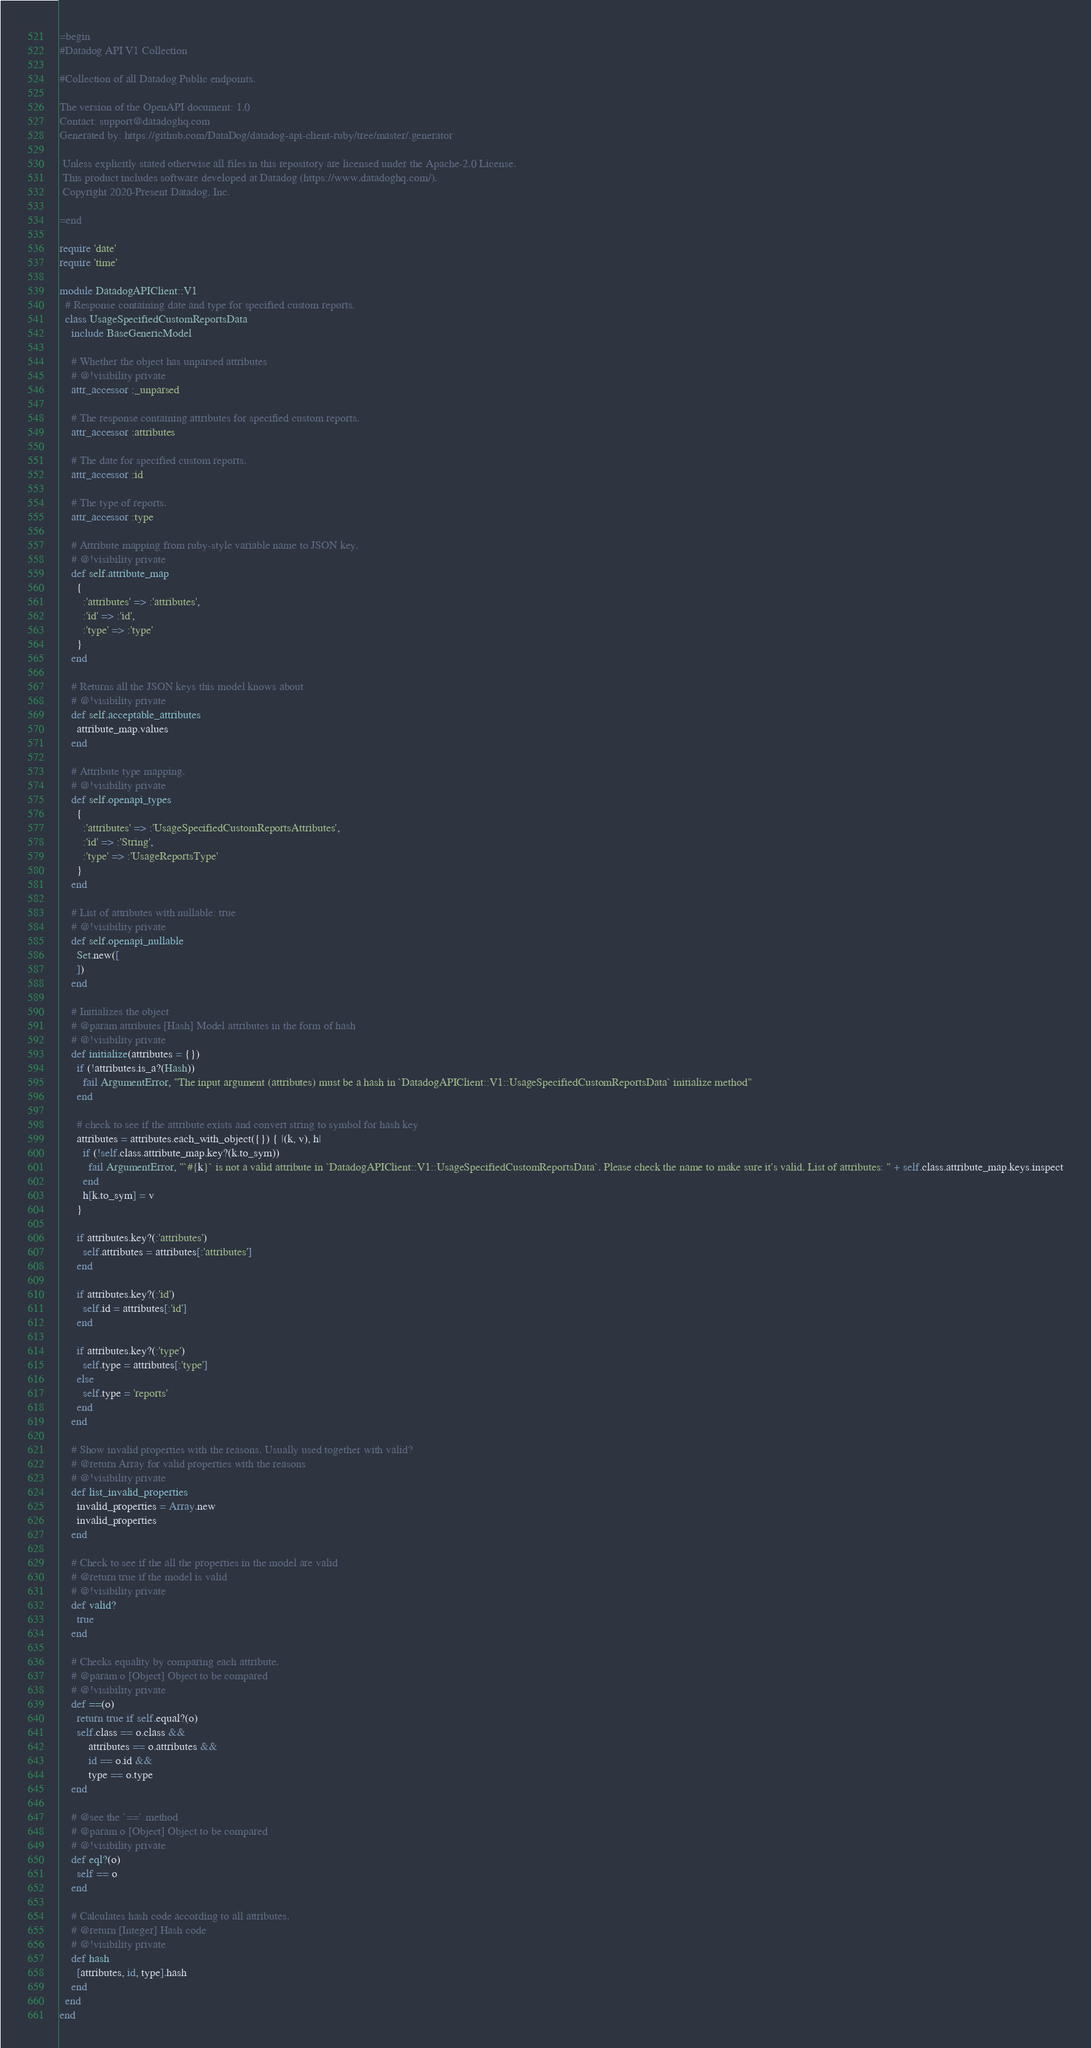<code> <loc_0><loc_0><loc_500><loc_500><_Ruby_>=begin
#Datadog API V1 Collection

#Collection of all Datadog Public endpoints.

The version of the OpenAPI document: 1.0
Contact: support@datadoghq.com
Generated by: https://github.com/DataDog/datadog-api-client-ruby/tree/master/.generator

 Unless explicitly stated otherwise all files in this repository are licensed under the Apache-2.0 License.
 This product includes software developed at Datadog (https://www.datadoghq.com/).
 Copyright 2020-Present Datadog, Inc.

=end

require 'date'
require 'time'

module DatadogAPIClient::V1
  # Response containing date and type for specified custom reports.
  class UsageSpecifiedCustomReportsData
    include BaseGenericModel

    # Whether the object has unparsed attributes
    # @!visibility private
    attr_accessor :_unparsed

    # The response containing attributes for specified custom reports.
    attr_accessor :attributes

    # The date for specified custom reports.
    attr_accessor :id

    # The type of reports.
    attr_accessor :type

    # Attribute mapping from ruby-style variable name to JSON key.
    # @!visibility private
    def self.attribute_map
      {
        :'attributes' => :'attributes',
        :'id' => :'id',
        :'type' => :'type'
      }
    end

    # Returns all the JSON keys this model knows about
    # @!visibility private
    def self.acceptable_attributes
      attribute_map.values
    end

    # Attribute type mapping.
    # @!visibility private
    def self.openapi_types
      {
        :'attributes' => :'UsageSpecifiedCustomReportsAttributes',
        :'id' => :'String',
        :'type' => :'UsageReportsType'
      }
    end

    # List of attributes with nullable: true
    # @!visibility private
    def self.openapi_nullable
      Set.new([
      ])
    end

    # Initializes the object
    # @param attributes [Hash] Model attributes in the form of hash
    # @!visibility private
    def initialize(attributes = {})
      if (!attributes.is_a?(Hash))
        fail ArgumentError, "The input argument (attributes) must be a hash in `DatadogAPIClient::V1::UsageSpecifiedCustomReportsData` initialize method"
      end

      # check to see if the attribute exists and convert string to symbol for hash key
      attributes = attributes.each_with_object({}) { |(k, v), h|
        if (!self.class.attribute_map.key?(k.to_sym))
          fail ArgumentError, "`#{k}` is not a valid attribute in `DatadogAPIClient::V1::UsageSpecifiedCustomReportsData`. Please check the name to make sure it's valid. List of attributes: " + self.class.attribute_map.keys.inspect
        end
        h[k.to_sym] = v
      }

      if attributes.key?(:'attributes')
        self.attributes = attributes[:'attributes']
      end

      if attributes.key?(:'id')
        self.id = attributes[:'id']
      end

      if attributes.key?(:'type')
        self.type = attributes[:'type']
      else
        self.type = 'reports'
      end
    end

    # Show invalid properties with the reasons. Usually used together with valid?
    # @return Array for valid properties with the reasons
    # @!visibility private
    def list_invalid_properties
      invalid_properties = Array.new
      invalid_properties
    end

    # Check to see if the all the properties in the model are valid
    # @return true if the model is valid
    # @!visibility private
    def valid?
      true
    end

    # Checks equality by comparing each attribute.
    # @param o [Object] Object to be compared
    # @!visibility private
    def ==(o)
      return true if self.equal?(o)
      self.class == o.class &&
          attributes == o.attributes &&
          id == o.id &&
          type == o.type
    end

    # @see the `==` method
    # @param o [Object] Object to be compared
    # @!visibility private
    def eql?(o)
      self == o
    end

    # Calculates hash code according to all attributes.
    # @return [Integer] Hash code
    # @!visibility private
    def hash
      [attributes, id, type].hash
    end
  end
end
</code> 